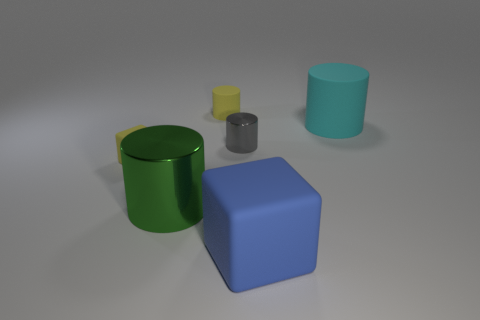Add 2 small blocks. How many objects exist? 8 Subtract all yellow matte cylinders. How many cylinders are left? 3 Subtract 1 cylinders. How many cylinders are left? 3 Subtract all green cylinders. How many cylinders are left? 3 Subtract all cylinders. How many objects are left? 2 Subtract all shiny objects. Subtract all blue matte blocks. How many objects are left? 3 Add 5 large matte objects. How many large matte objects are left? 7 Add 6 large things. How many large things exist? 9 Subtract 1 blue blocks. How many objects are left? 5 Subtract all green blocks. Subtract all purple cylinders. How many blocks are left? 2 